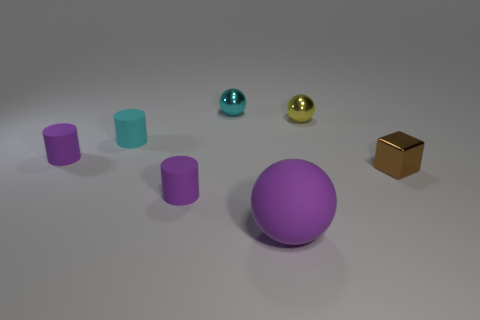Is there anything else of the same color as the large thing?
Provide a short and direct response. Yes. Is there a sphere in front of the cyan object to the left of the small matte cylinder that is in front of the small cube?
Keep it short and to the point. Yes. There is a tiny thing that is in front of the cube; does it have the same color as the rubber sphere?
Give a very brief answer. Yes. How many cubes are either small rubber things or cyan matte things?
Your answer should be compact. 0. The tiny rubber object behind the purple cylinder behind the brown metallic block is what shape?
Provide a short and direct response. Cylinder. What size is the sphere in front of the tiny metal object that is on the right side of the tiny shiny sphere in front of the cyan metallic object?
Your answer should be compact. Large. Does the yellow object have the same size as the cyan cylinder?
Ensure brevity in your answer.  Yes. How many objects are small gray shiny spheres or small brown things?
Provide a short and direct response. 1. How big is the metallic ball that is to the right of the metal thing left of the large purple object?
Provide a short and direct response. Small. What is the size of the cyan metal sphere?
Give a very brief answer. Small. 